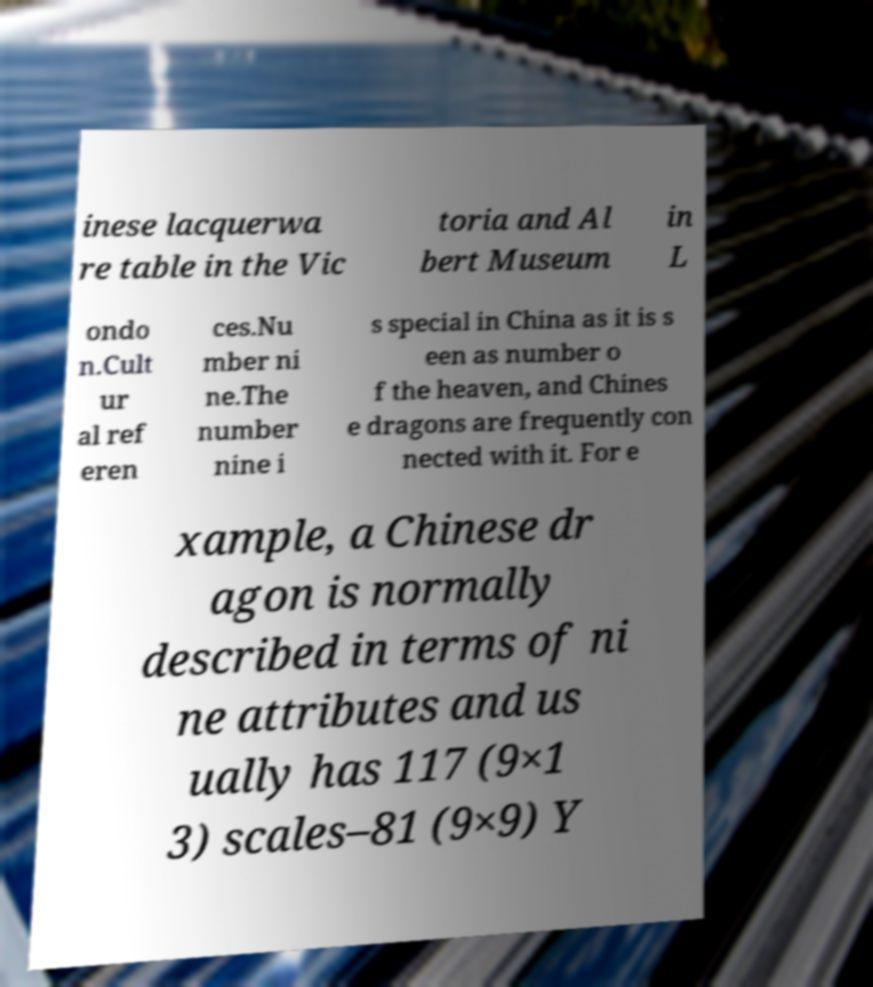For documentation purposes, I need the text within this image transcribed. Could you provide that? inese lacquerwa re table in the Vic toria and Al bert Museum in L ondo n.Cult ur al ref eren ces.Nu mber ni ne.The number nine i s special in China as it is s een as number o f the heaven, and Chines e dragons are frequently con nected with it. For e xample, a Chinese dr agon is normally described in terms of ni ne attributes and us ually has 117 (9×1 3) scales–81 (9×9) Y 